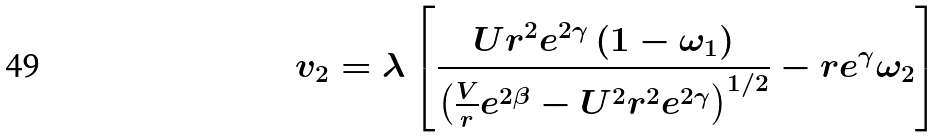Convert formula to latex. <formula><loc_0><loc_0><loc_500><loc_500>v _ { 2 } = \lambda \left [ \frac { U r ^ { 2 } e ^ { 2 \gamma } \left ( 1 - \omega _ { 1 } \right ) } { \left ( \frac { V } { r } e ^ { 2 \beta } - U ^ { 2 } r ^ { 2 } e ^ { 2 \gamma } \right ) ^ { 1 / 2 } } - r e ^ { \gamma } \omega _ { 2 } \right ]</formula> 